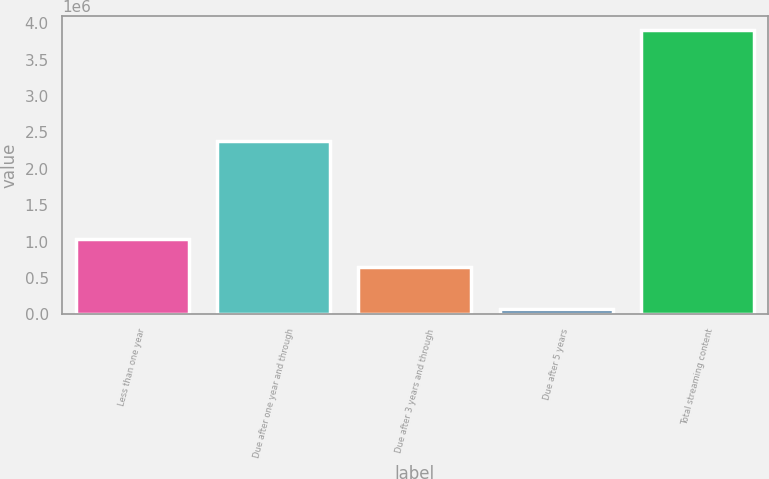Convert chart to OTSL. <chart><loc_0><loc_0><loc_500><loc_500><bar_chart><fcel>Less than one year<fcel>Due after one year and through<fcel>Due after 3 years and through<fcel>Due after 5 years<fcel>Total streaming content<nl><fcel>1.03373e+06<fcel>2.38437e+06<fcel>650480<fcel>74696<fcel>3.9072e+06<nl></chart> 